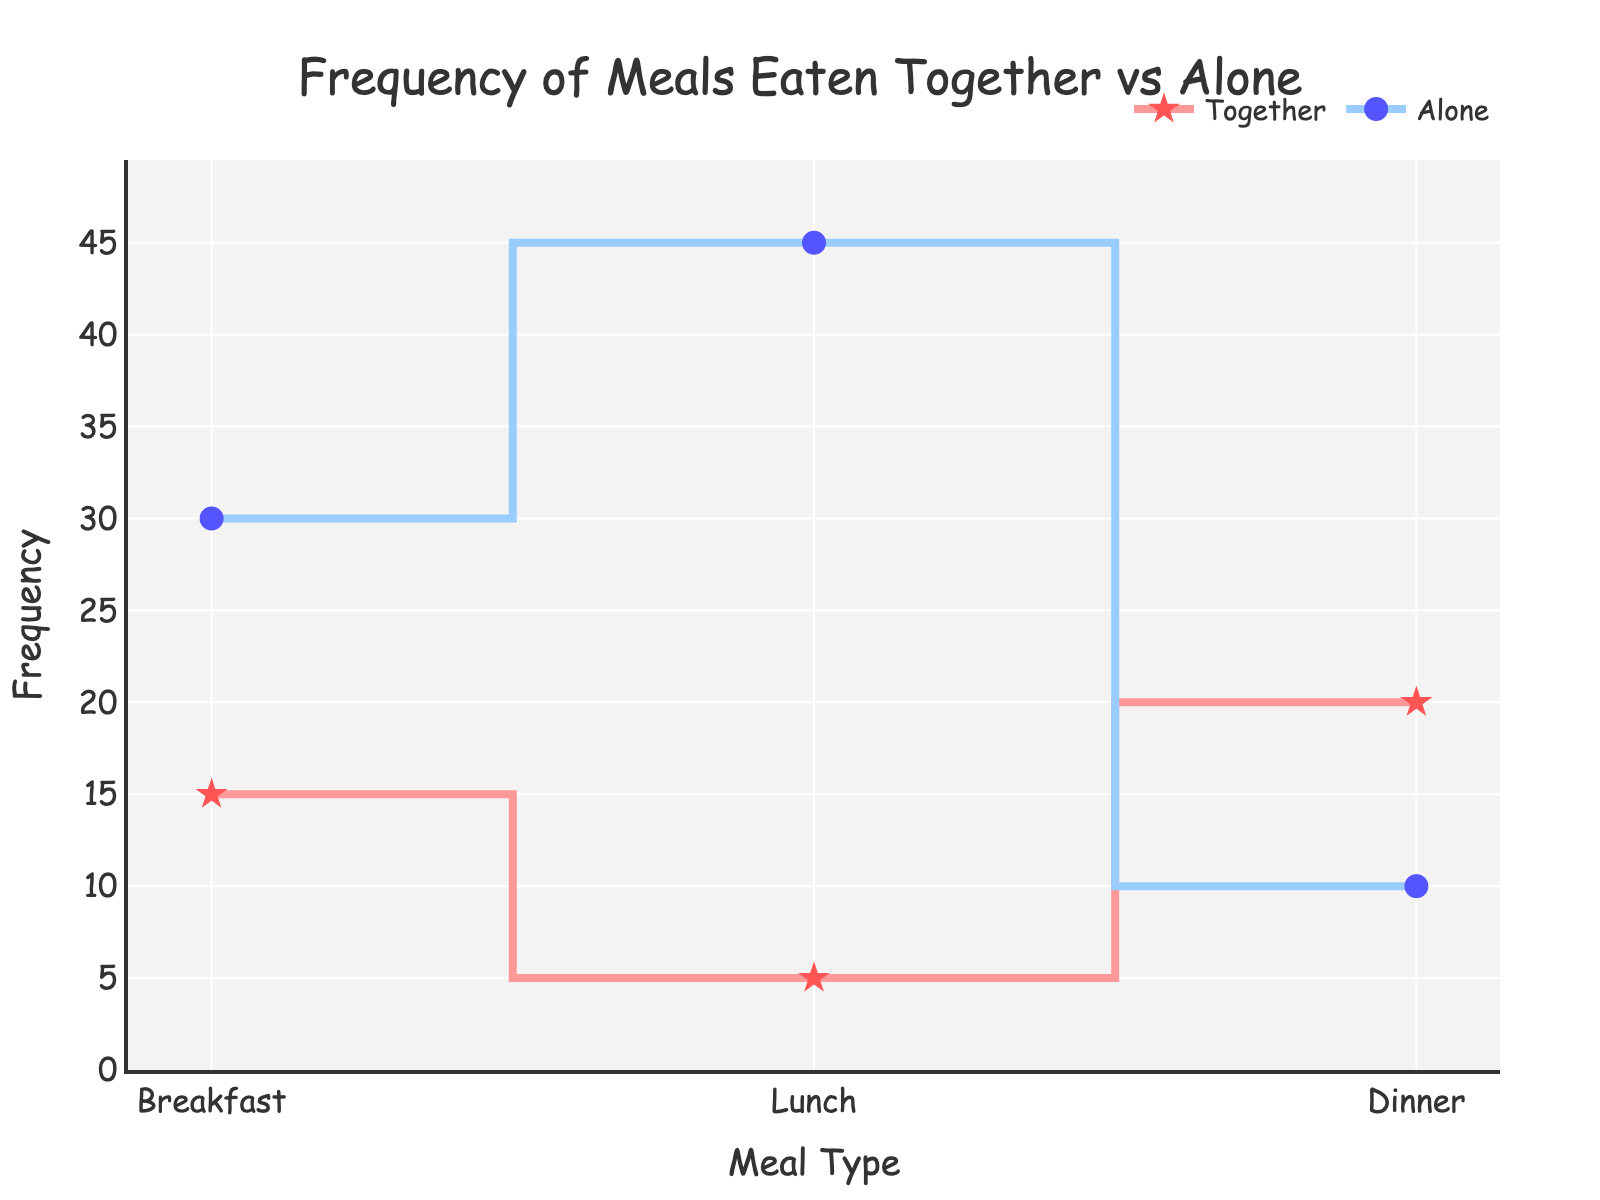what is the title of the plot? The title is usually located at the top of the plot and provides a summary of what the plot represents. Here, the title is "Frequency of Meals Eaten Together vs Alone".
Answer: Frequency of Meals Eaten Together vs Alone What meal type eaten alone has the highest frequency? To identify the meal type with the highest frequency when eaten alone, look at the data points with "Alone" in their labels. Here, "Lunch Alone" has the highest frequency at 45.
Answer: Lunch Alone How many meal types are eaten together and how many are eaten alone? Count the data points with "Together" and "Alone" in their labels. There are 3 "Together" and 3 "Alone" meal types.
Answer: 3 Together, 3 Alone Which meal type is the most frequently eaten together? Identify the data point with "Together" that has the highest frequency. "Dinner Together" has the highest frequency at 20.
Answer: Dinner Together What is the combined frequency of Breakfast Together and Breakfast Alone? Add the frequency of "Breakfast Together" (15) and "Breakfast Alone" (30). The combined frequency is 15 + 30 = 45.
Answer: 45 Which meal type shows the largest difference in frequency when eaten alone vs together? Calculate the difference for each meal type between eating alone and together. The differences are: Breakfast (30 - 15 = 15), Lunch (45 - 5 = 40), and Dinner (20 - 10 = 10). The largest difference is for Lunch with 40.
Answer: Lunch Are more meals eaten together or alone overall? Sum the frequencies of all "Together" meals and all "Alone" meals. Together: 15 + 5 + 20 = 40, Alone: 30 + 45 + 10 = 85. More meals are eaten alone.
Answer: Alone Which type of meal has the least variation in the frequency between eating together and eating alone? Calculate the differences as before: Breakfast (30 - 15 = 15), Lunch (45 - 5 = 40), and Dinner (20 - 10 = 10). The least variation is for Dinner with 10.
Answer: Dinner What is the total frequency for all meal types listed in the plot? Add the frequencies of all meal types: 15 + 5 + 20 + 30 + 45 + 10 = 125.
Answer: 125 Is there any meal type that has the same frequency for both together and alone? Compare the frequencies of "Together" and "Alone" for each meal type. None of the meal types have the same frequency for both eating together and alone.
Answer: No 